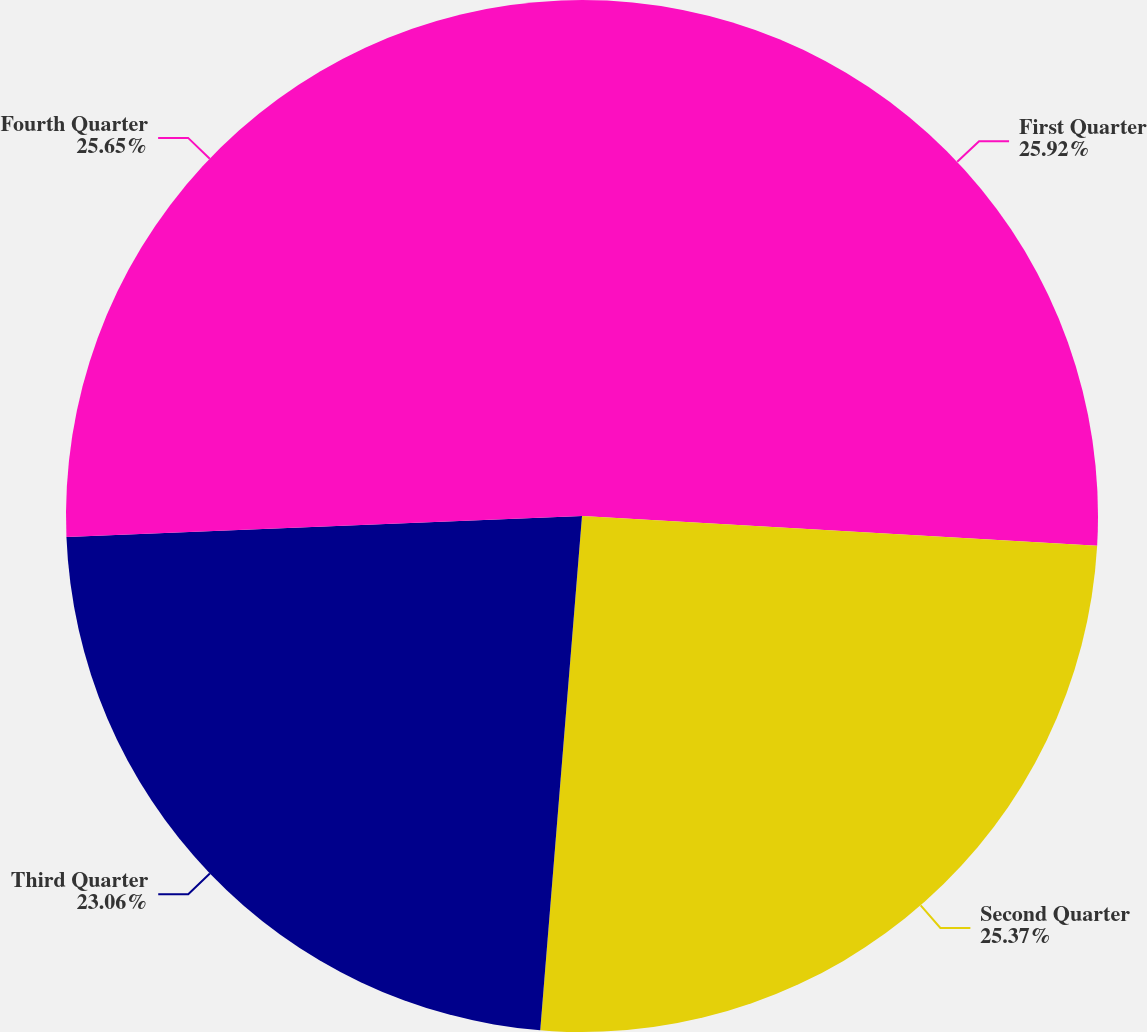<chart> <loc_0><loc_0><loc_500><loc_500><pie_chart><fcel>First Quarter<fcel>Second Quarter<fcel>Third Quarter<fcel>Fourth Quarter<nl><fcel>25.92%<fcel>25.37%<fcel>23.06%<fcel>25.65%<nl></chart> 